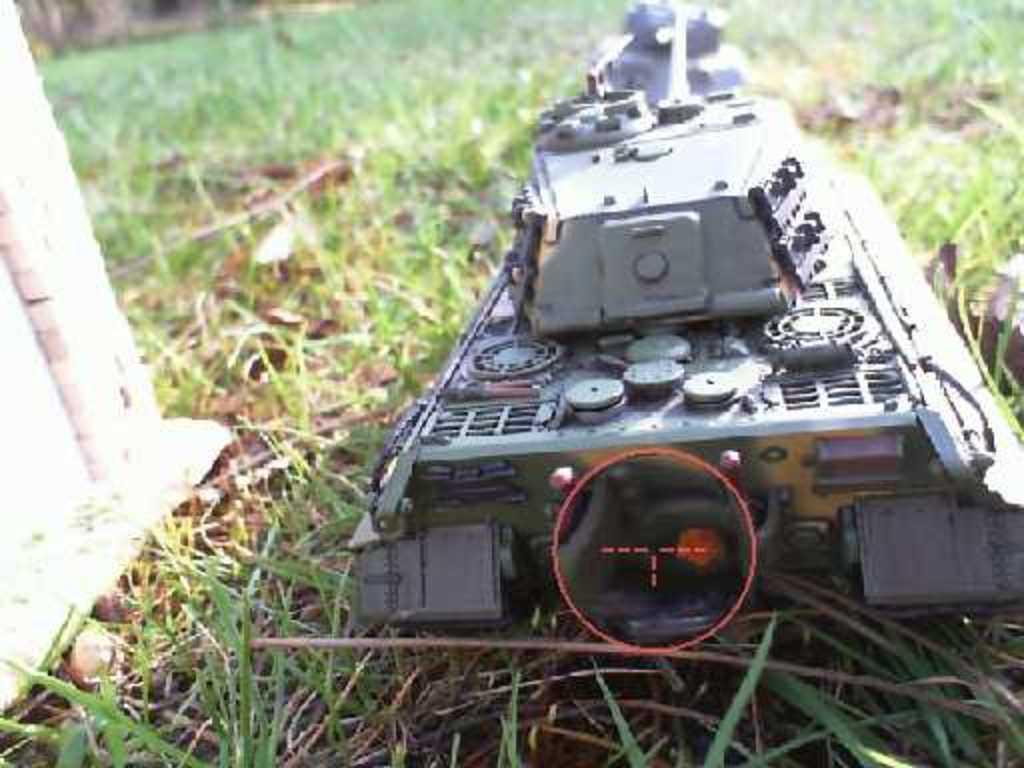Could you give a brief overview of what you see in this image? In this image, we can see an object on the ground covered with grass. We can see a white colored object on the left. 